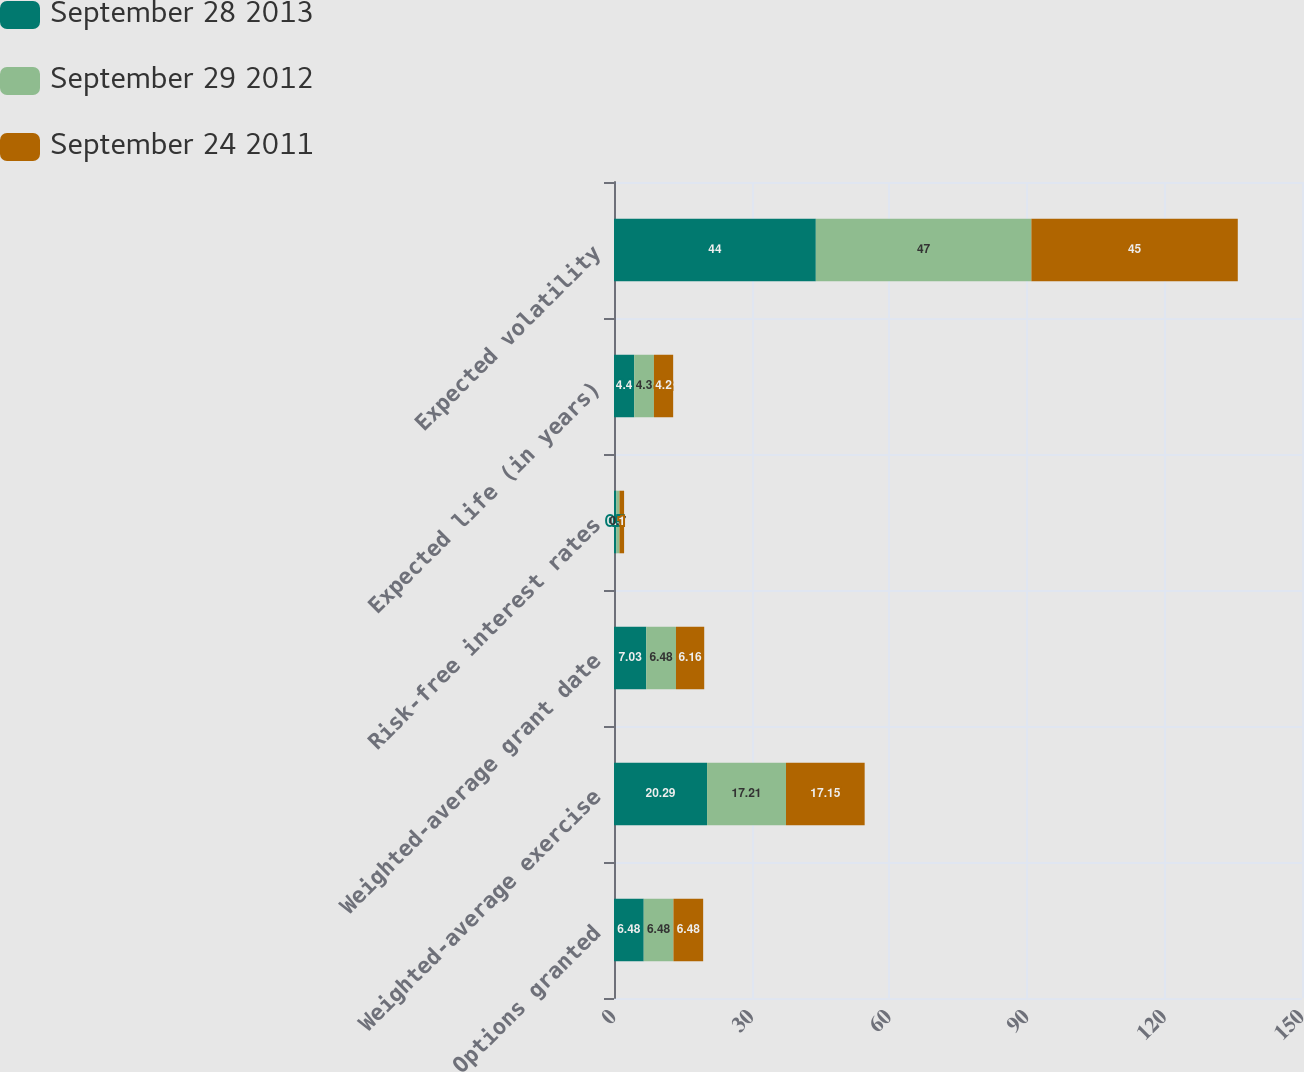<chart> <loc_0><loc_0><loc_500><loc_500><stacked_bar_chart><ecel><fcel>Options granted<fcel>Weighted-average exercise<fcel>Weighted-average grant date<fcel>Risk-free interest rates<fcel>Expected life (in years)<fcel>Expected volatility<nl><fcel>September 28 2013<fcel>6.48<fcel>20.29<fcel>7.03<fcel>0.5<fcel>4.4<fcel>44<nl><fcel>September 29 2012<fcel>6.48<fcel>17.21<fcel>6.48<fcel>0.7<fcel>4.3<fcel>47<nl><fcel>September 24 2011<fcel>6.48<fcel>17.15<fcel>6.16<fcel>1<fcel>4.2<fcel>45<nl></chart> 